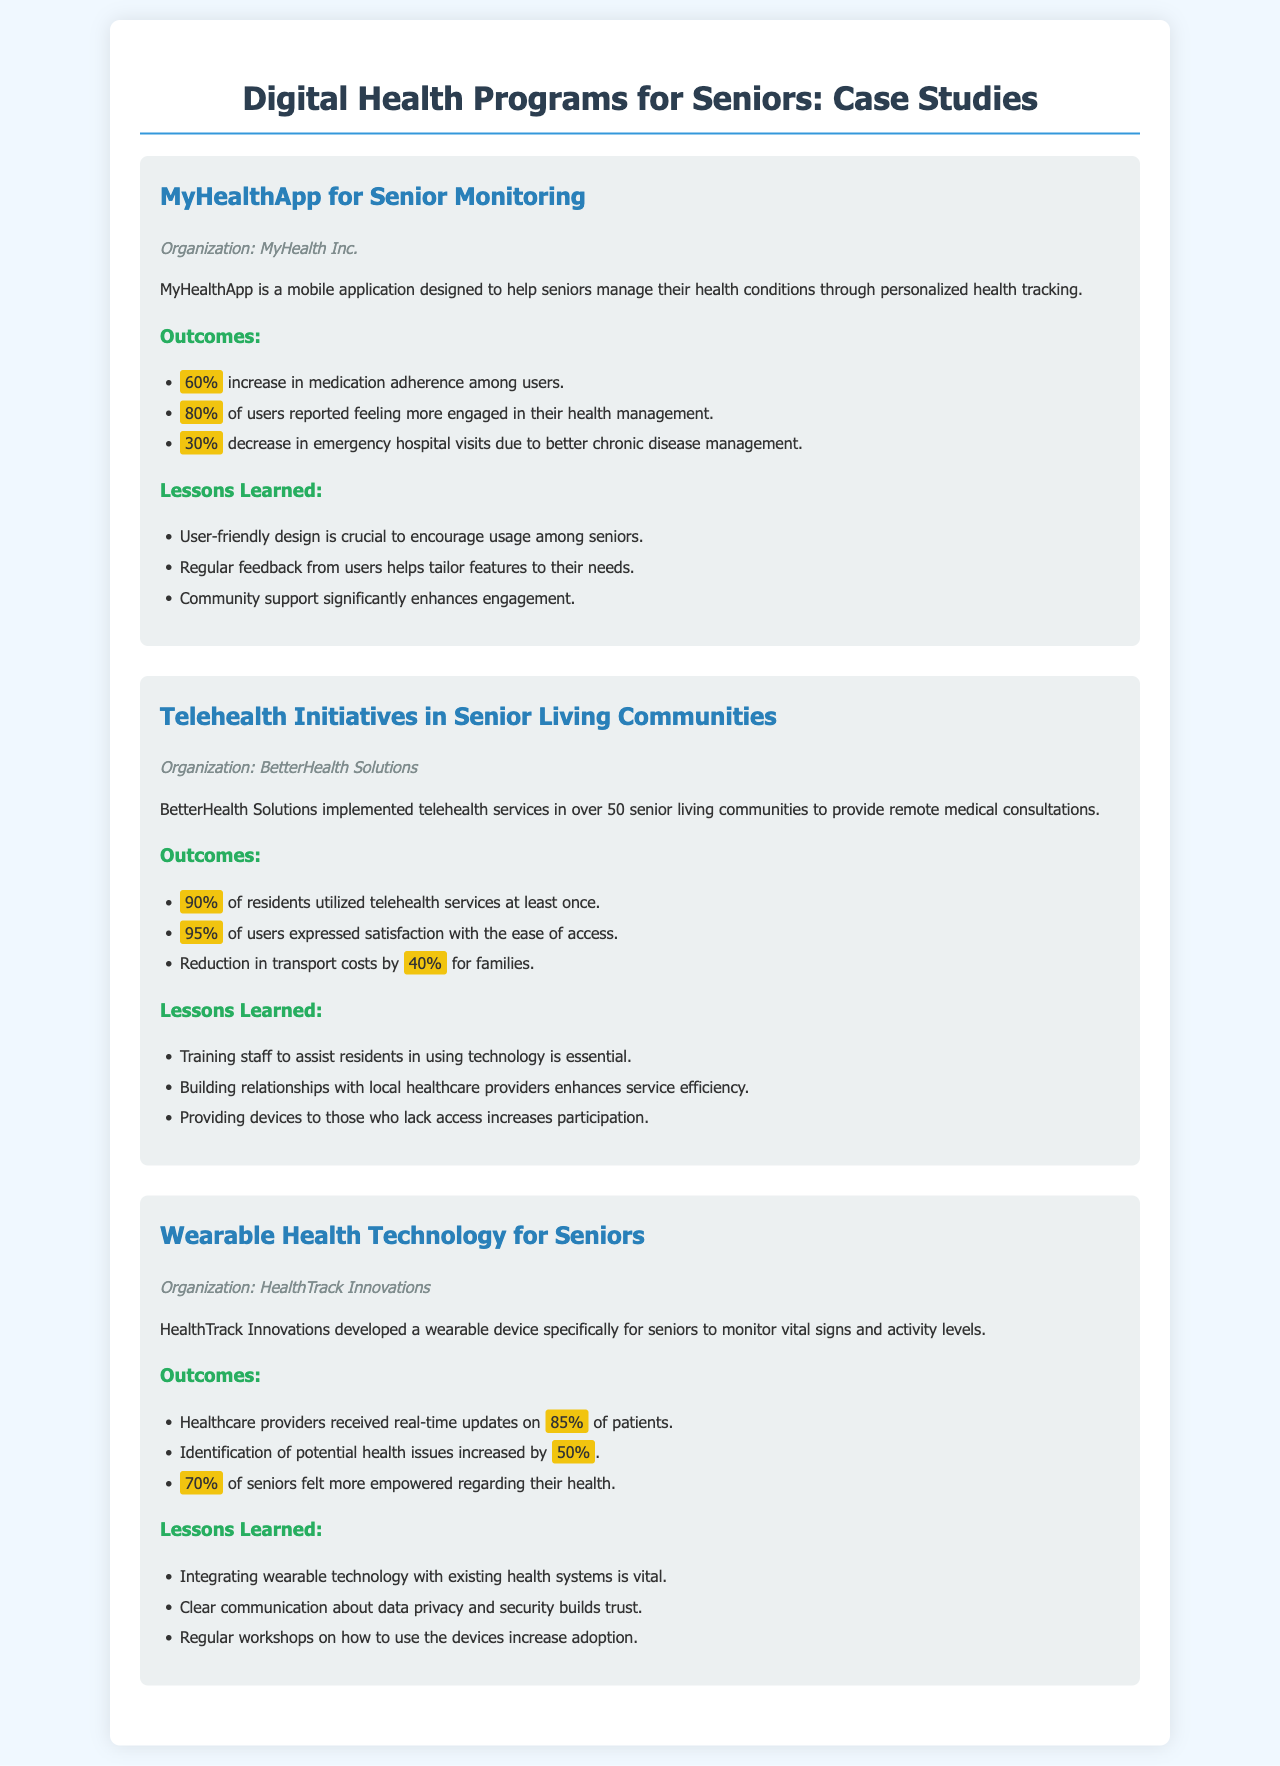What is the name of the mobile application for health management? The document mentions a specific mobile application designed for seniors, which is MyHealthApp.
Answer: MyHealthApp Who implemented telehealth services in senior living communities? The document attributes the implementation of telehealth services to BetterHealth Solutions.
Answer: BetterHealth Solutions What percentage of users reported feeling more engaged in their health management while using MyHealthApp? According to the outcomes, 80% of users reported feeling more engaged in their health management while using MyHealthApp.
Answer: 80% What was the reduction in transport costs for families using telehealth services? The document states that there was a reduction in transport costs by 40% for families.
Answer: 40% What organization developed wearable health technology for seniors? The document specifies that HealthTrack Innovations developed a wearable device for seniors.
Answer: HealthTrack Innovations What percentage of seniors felt more empowered regarding their health using wearable technology? The outcomes indicate that 70% of seniors felt more empowered regarding their health while using the wearable technology.
Answer: 70% What is a crucial lesson learned about user-friendly design? One of the lessons learned is that user-friendly design is crucial to encourage usage among seniors.
Answer: User-friendly design is crucial How many senior living communities were included in the telehealth initiatives? The document mentions that telehealth services were implemented in over 50 senior living communities.
Answer: Over 50 What factor significantly enhances engagement according to MyHealthApp's case study? The case study mentions that community support significantly enhances engagement with MyHealthApp.
Answer: Community support What percentage of healthcare providers received real-time updates from patients using wearable devices? The outcomes specify that healthcare providers received real-time updates on 85% of patients using the wearable devices.
Answer: 85% 